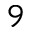Convert formula to latex. <formula><loc_0><loc_0><loc_500><loc_500>^ { 9 }</formula> 